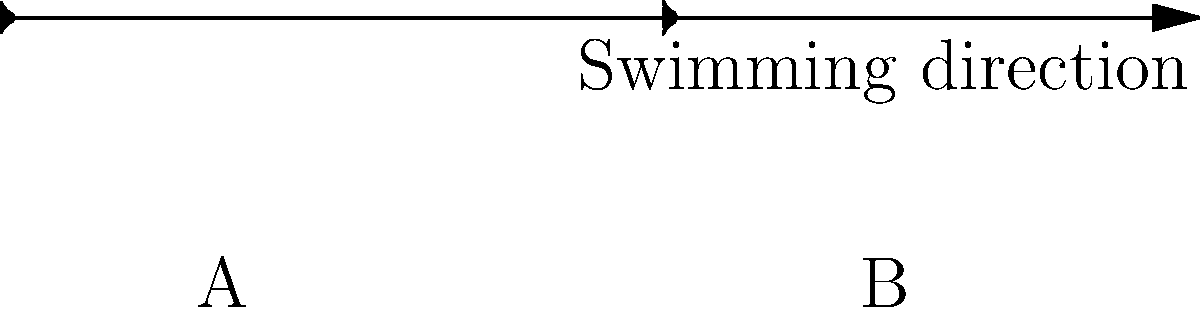As a tropical fish enthusiast, you're studying the relationship between fish body shape and swimming efficiency. The image shows streamline visualizations around two different fish body shapes (A and B) moving through water. Based on these visualizations, which fish shape is likely to be more energy-efficient for sustained swimming, and why? To answer this question, we need to analyze the streamline patterns around each fish shape and understand how they relate to swimming efficiency. Let's break it down step-by-step:

1. Streamline analysis:
   a) Fish A: The streamlines are more parallel and closely follow the body contour.
   b) Fish B: The streamlines are more curved and diverge from the body, especially near the widest part.

2. Drag force:
   Drag force is proportional to the cross-sectional area perpendicular to the flow. A larger area results in higher drag.
   a) Fish A: Smaller cross-sectional area due to its more elongated shape.
   b) Fish B: Larger cross-sectional area due to its wider body.

3. Flow separation:
   Flow separation occurs when streamlines detach from the body surface, creating turbulence and increasing drag.
   a) Fish A: Minimal flow separation due to gradual tapering of the body.
   b) Fish B: More likely to experience flow separation near its widest point.

4. Pressure distribution:
   a) Fish A: More uniform pressure distribution along the body, resulting in less form drag.
   b) Fish B: Larger pressure difference between front and back, leading to increased form drag.

5. Energy efficiency:
   Energy efficiency in swimming is inversely related to the total drag force experienced by the fish.
   a) Fish A: Lower drag forces lead to higher energy efficiency.
   b) Fish B: Higher drag forces result in lower energy efficiency.

6. Evolutionary adaptations:
   Many fast-swimming fish species have evolved body shapes similar to Fish A, optimized for sustained swimming in open water.

Based on these factors, Fish A's more streamlined shape is likely to be more energy-efficient for sustained swimming. Its body shape minimizes drag and flow separation, allowing it to move through water with less energy expenditure.
Answer: Fish A, due to its more streamlined shape that minimizes drag and flow separation. 